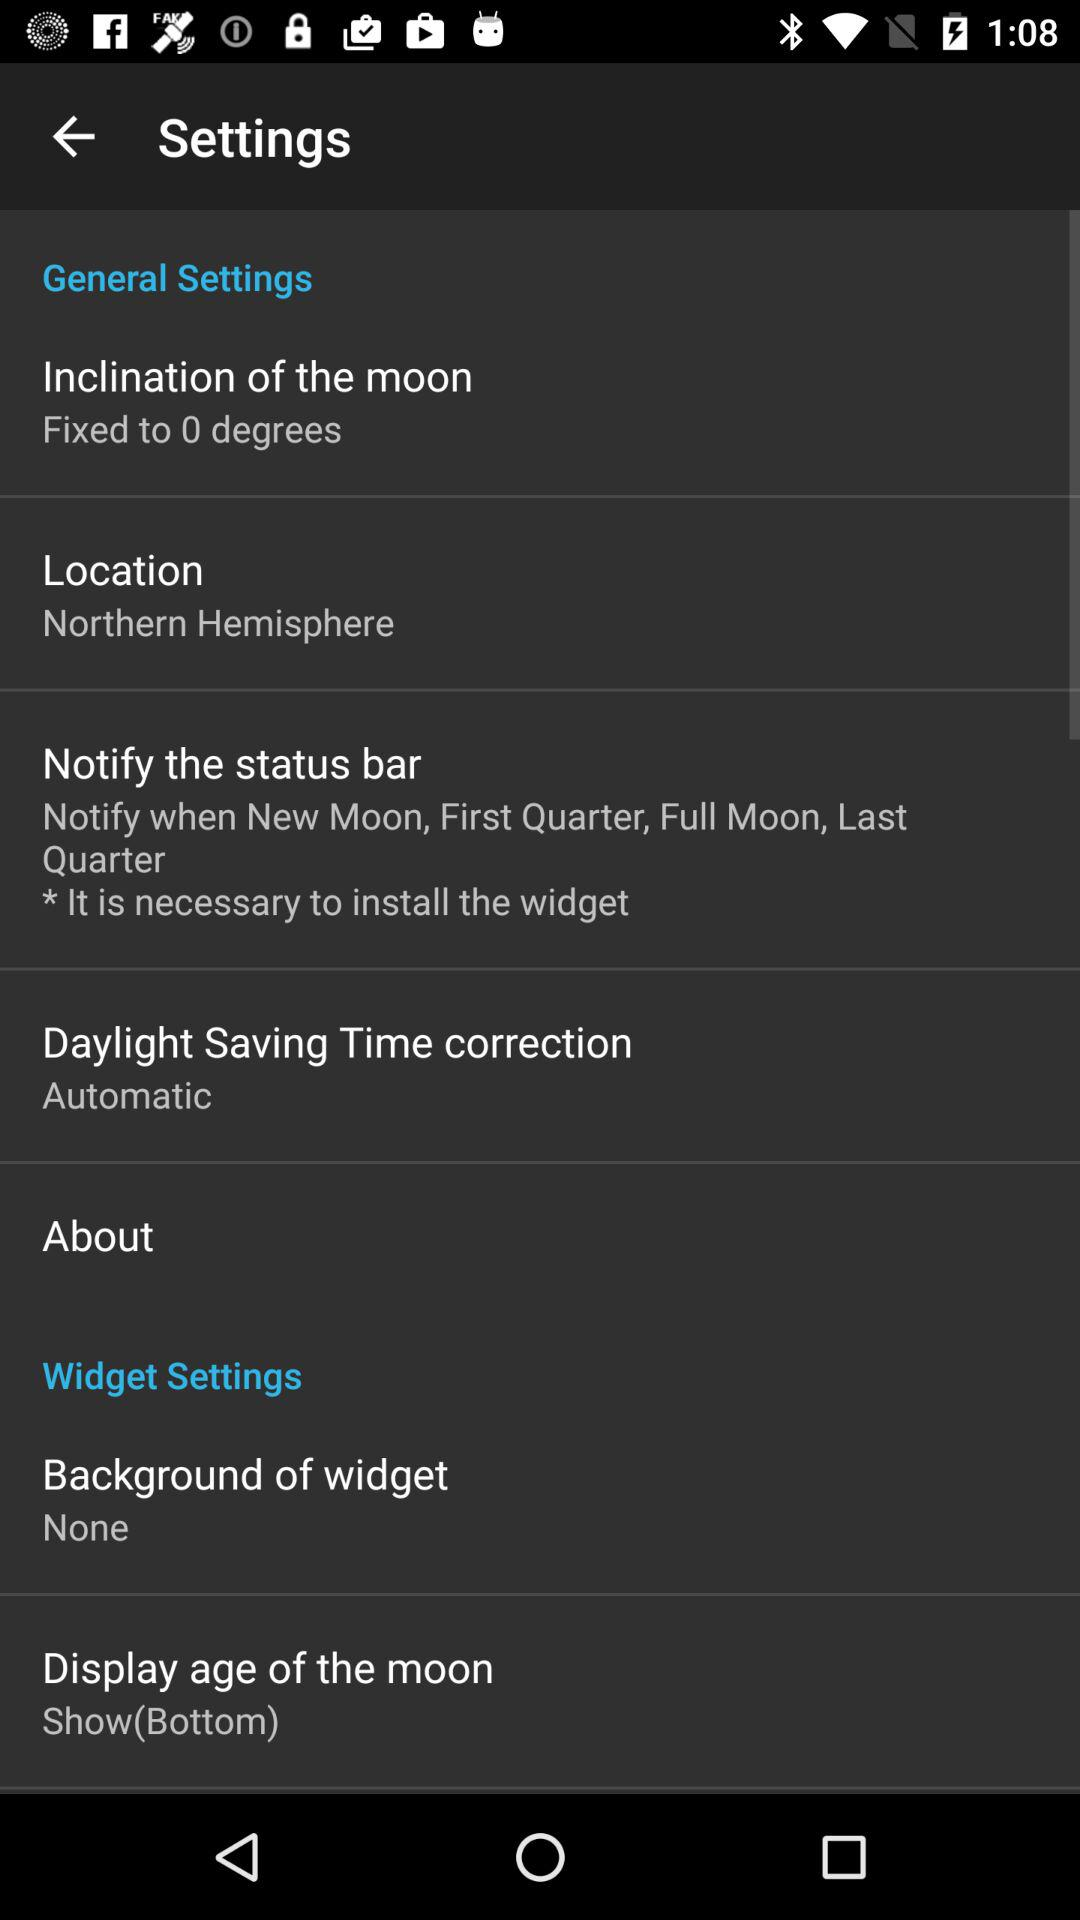What is the mentioned location? The mentioned location is the Northern Hemisphere. 